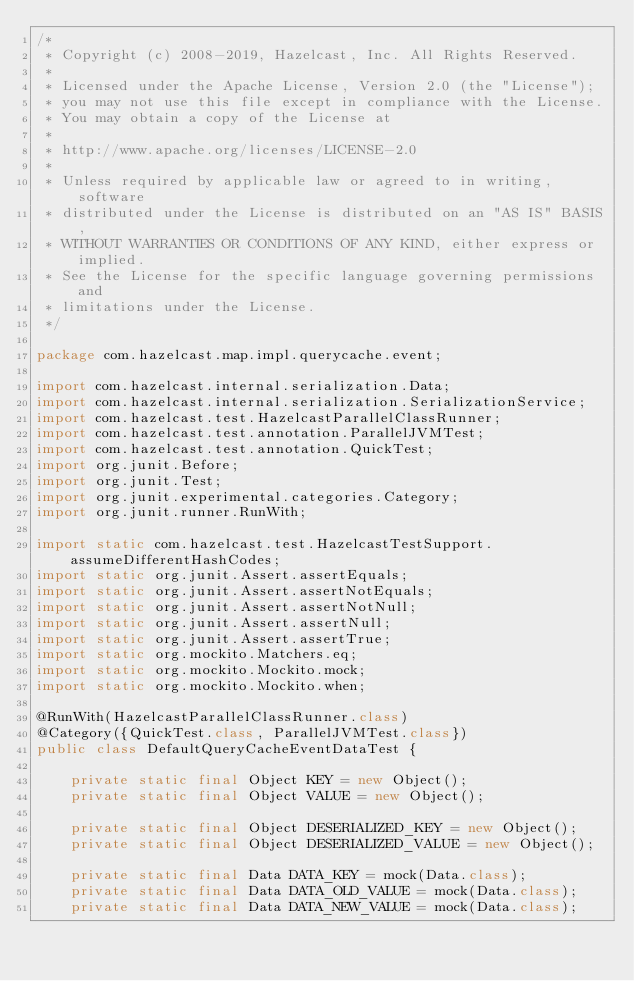<code> <loc_0><loc_0><loc_500><loc_500><_Java_>/*
 * Copyright (c) 2008-2019, Hazelcast, Inc. All Rights Reserved.
 *
 * Licensed under the Apache License, Version 2.0 (the "License");
 * you may not use this file except in compliance with the License.
 * You may obtain a copy of the License at
 *
 * http://www.apache.org/licenses/LICENSE-2.0
 *
 * Unless required by applicable law or agreed to in writing, software
 * distributed under the License is distributed on an "AS IS" BASIS,
 * WITHOUT WARRANTIES OR CONDITIONS OF ANY KIND, either express or implied.
 * See the License for the specific language governing permissions and
 * limitations under the License.
 */

package com.hazelcast.map.impl.querycache.event;

import com.hazelcast.internal.serialization.Data;
import com.hazelcast.internal.serialization.SerializationService;
import com.hazelcast.test.HazelcastParallelClassRunner;
import com.hazelcast.test.annotation.ParallelJVMTest;
import com.hazelcast.test.annotation.QuickTest;
import org.junit.Before;
import org.junit.Test;
import org.junit.experimental.categories.Category;
import org.junit.runner.RunWith;

import static com.hazelcast.test.HazelcastTestSupport.assumeDifferentHashCodes;
import static org.junit.Assert.assertEquals;
import static org.junit.Assert.assertNotEquals;
import static org.junit.Assert.assertNotNull;
import static org.junit.Assert.assertNull;
import static org.junit.Assert.assertTrue;
import static org.mockito.Matchers.eq;
import static org.mockito.Mockito.mock;
import static org.mockito.Mockito.when;

@RunWith(HazelcastParallelClassRunner.class)
@Category({QuickTest.class, ParallelJVMTest.class})
public class DefaultQueryCacheEventDataTest {

    private static final Object KEY = new Object();
    private static final Object VALUE = new Object();

    private static final Object DESERIALIZED_KEY = new Object();
    private static final Object DESERIALIZED_VALUE = new Object();

    private static final Data DATA_KEY = mock(Data.class);
    private static final Data DATA_OLD_VALUE = mock(Data.class);
    private static final Data DATA_NEW_VALUE = mock(Data.class);
</code> 